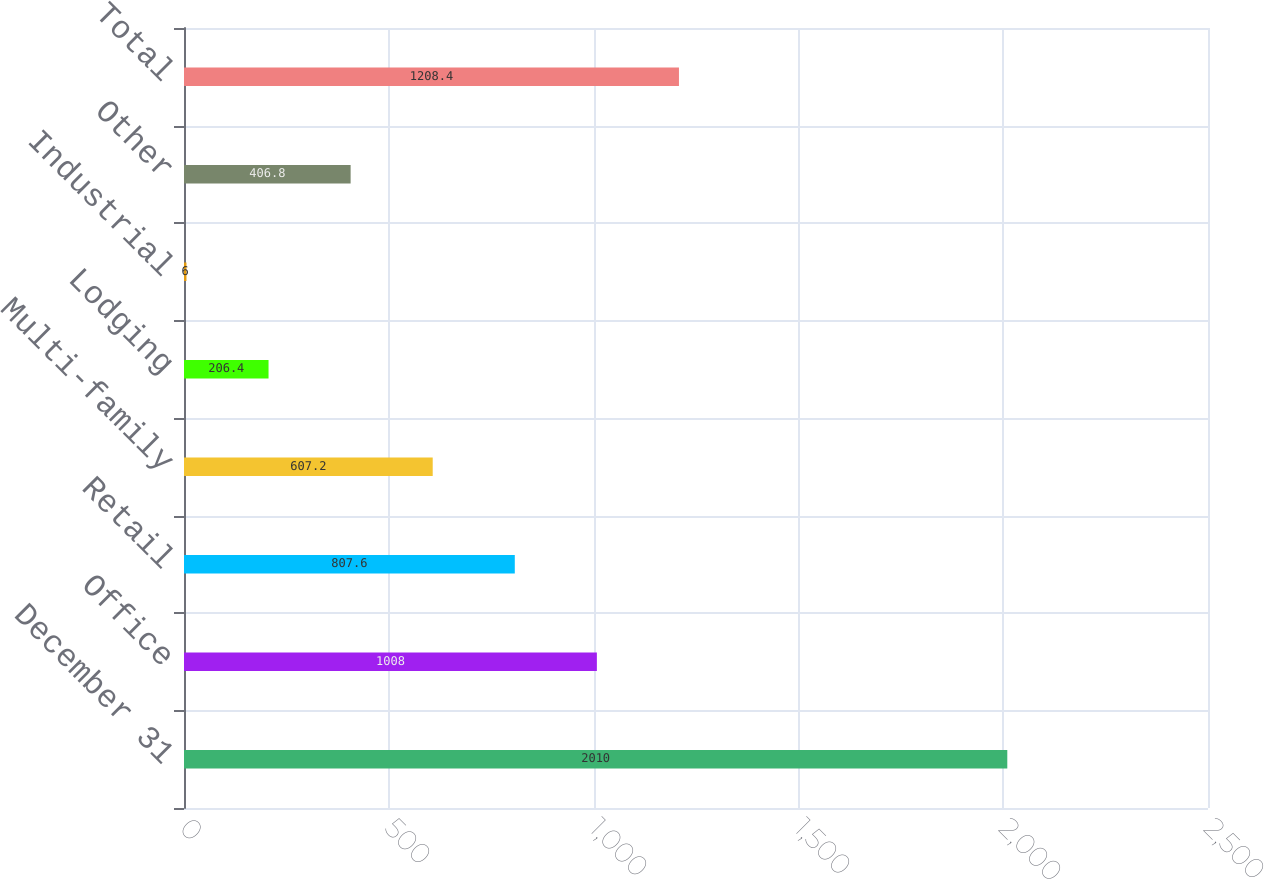Convert chart to OTSL. <chart><loc_0><loc_0><loc_500><loc_500><bar_chart><fcel>December 31<fcel>Office<fcel>Retail<fcel>Multi-family<fcel>Lodging<fcel>Industrial<fcel>Other<fcel>Total<nl><fcel>2010<fcel>1008<fcel>807.6<fcel>607.2<fcel>206.4<fcel>6<fcel>406.8<fcel>1208.4<nl></chart> 